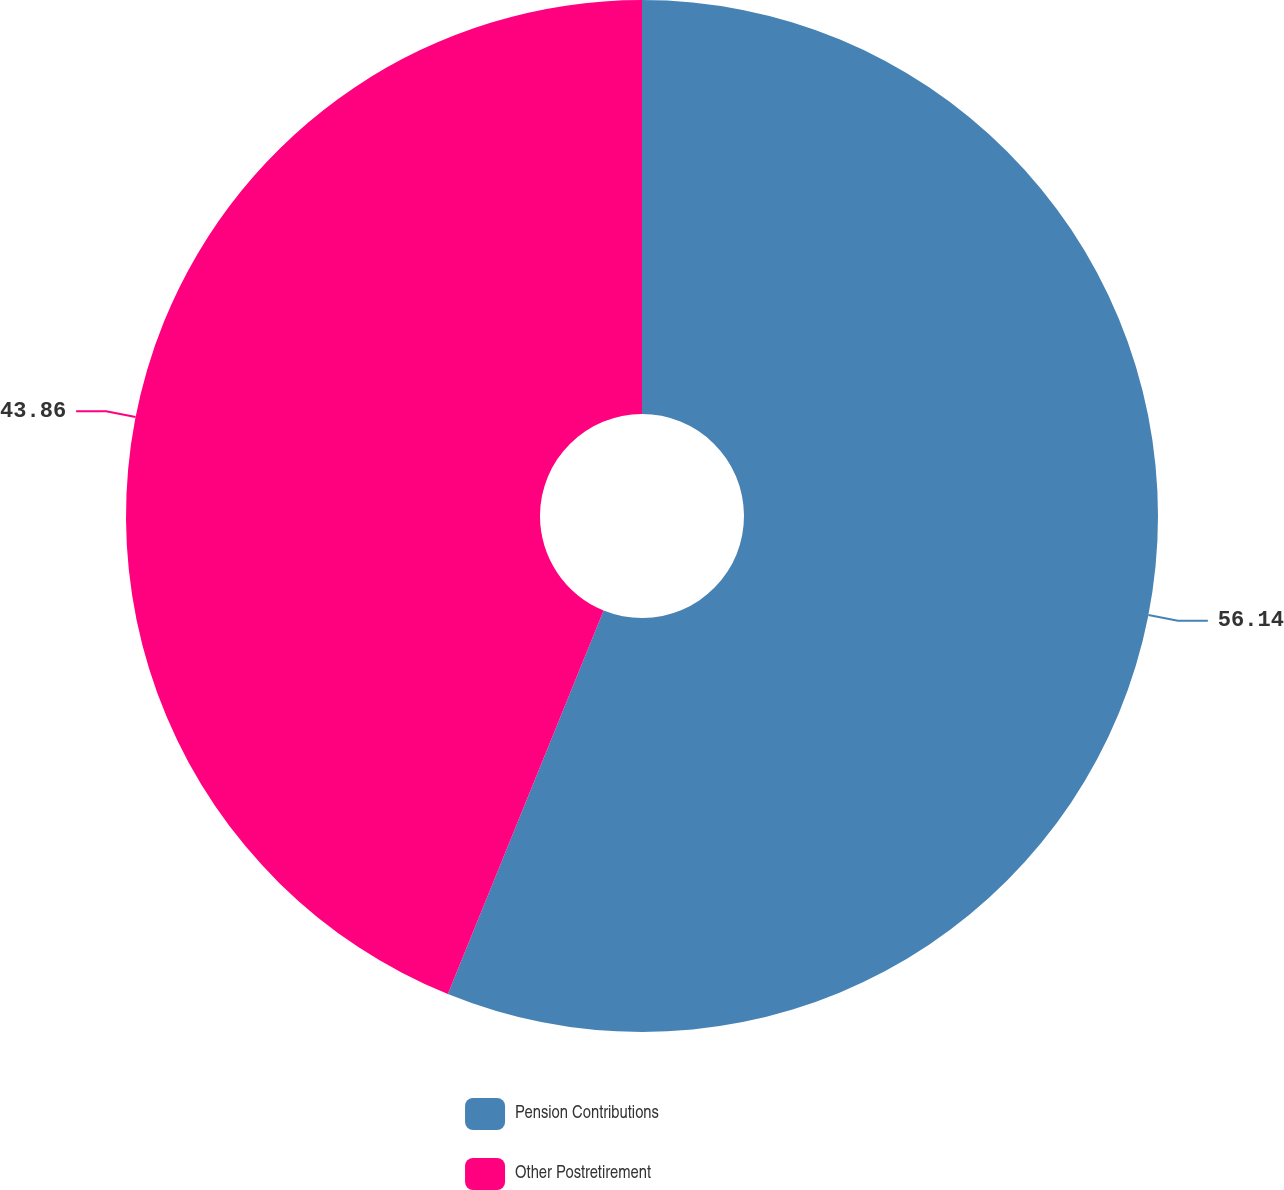<chart> <loc_0><loc_0><loc_500><loc_500><pie_chart><fcel>Pension Contributions<fcel>Other Postretirement<nl><fcel>56.14%<fcel>43.86%<nl></chart> 